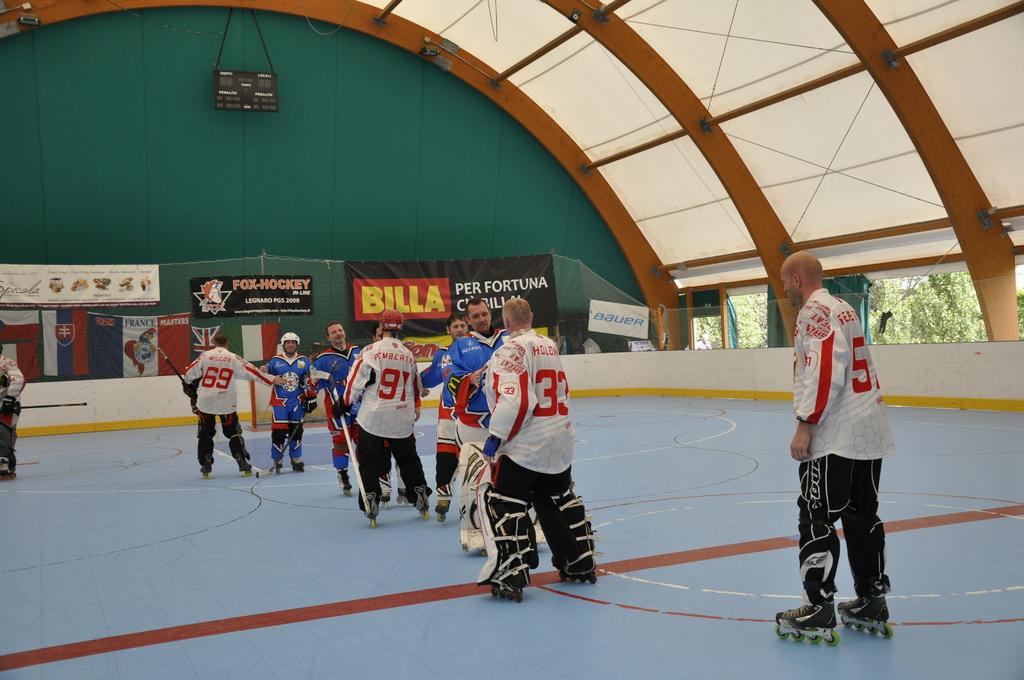What number is the goalie in white?
Give a very brief answer. 33. 